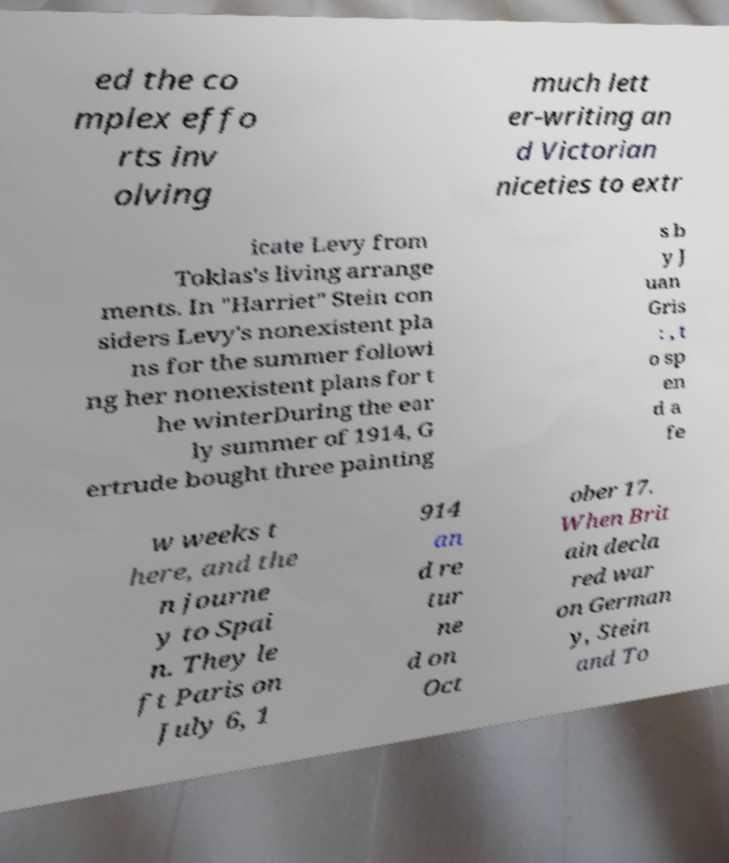What messages or text are displayed in this image? I need them in a readable, typed format. ed the co mplex effo rts inv olving much lett er-writing an d Victorian niceties to extr icate Levy from Toklas's living arrange ments. In "Harriet" Stein con siders Levy's nonexistent pla ns for the summer followi ng her nonexistent plans for t he winterDuring the ear ly summer of 1914, G ertrude bought three painting s b y J uan Gris : , t o sp en d a fe w weeks t here, and the n journe y to Spai n. They le ft Paris on July 6, 1 914 an d re tur ne d on Oct ober 17. When Brit ain decla red war on German y, Stein and To 